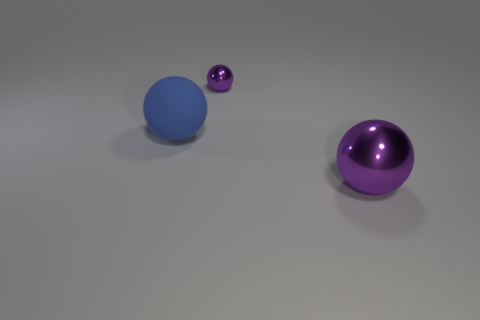Are there any other things that have the same material as the big blue object?
Provide a succinct answer. No. There is another ball that is the same color as the small sphere; what is its size?
Offer a very short reply. Large. What number of objects are balls or metallic balls?
Make the answer very short. 3. What material is the large sphere that is to the left of the thing that is right of the small purple thing?
Your response must be concise. Rubber. Are there any large rubber balls of the same color as the small metal object?
Your answer should be compact. No. What is the color of the metal object that is the same size as the blue ball?
Make the answer very short. Purple. What is the big object behind the purple object that is on the right side of the small thing that is behind the blue ball made of?
Provide a succinct answer. Rubber. Do the rubber object and the big thing in front of the large blue ball have the same color?
Keep it short and to the point. No. How many objects are either things that are in front of the blue rubber object or purple spheres in front of the tiny thing?
Your answer should be very brief. 1. What is the shape of the purple shiny thing that is behind the large sphere that is left of the big shiny sphere?
Ensure brevity in your answer.  Sphere. 